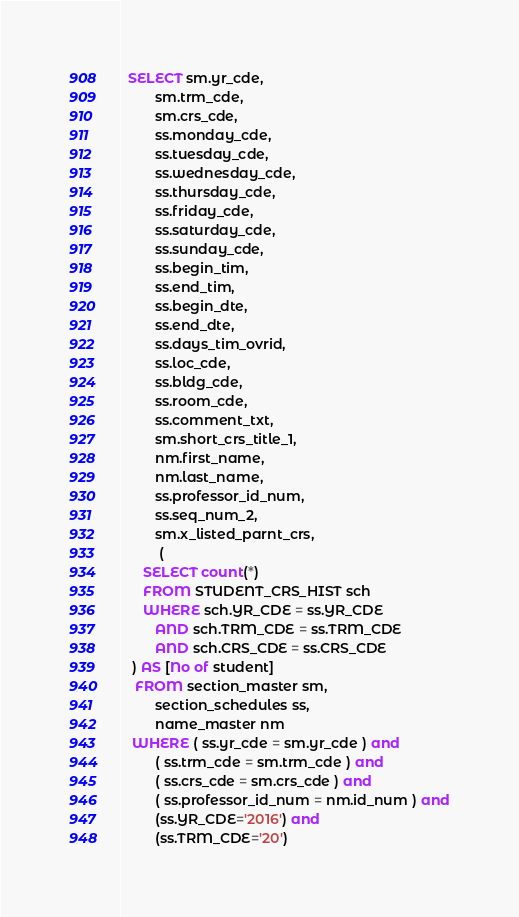Convert code to text. <code><loc_0><loc_0><loc_500><loc_500><_SQL_>  SELECT sm.yr_cde,   
         sm.trm_cde,   
         sm.crs_cde,   
         ss.monday_cde,   
         ss.tuesday_cde,   
         ss.wednesday_cde,   
         ss.thursday_cde,   
         ss.friday_cde,   
         ss.saturday_cde,   
         ss.sunday_cde,   
         ss.begin_tim,   
         ss.end_tim,   
         ss.begin_dte,   
         ss.end_dte,   
         ss.days_tim_ovrid,   
         ss.loc_cde,   
         ss.bldg_cde,   
         ss.room_cde,   
         ss.comment_txt,   
         sm.short_crs_title_1,   
         nm.first_name,   
         nm.last_name,   
         ss.professor_id_num,   
         ss.seq_num_2,   
         sm.x_listed_parnt_crs,
		  (
      SELECT count(*)
      FROM STUDENT_CRS_HIST sch
      WHERE sch.YR_CDE = ss.YR_CDE
         AND sch.TRM_CDE = ss.TRM_CDE
         AND sch.CRS_CDE = ss.CRS_CDE
   ) AS [No of student] 
    FROM section_master sm,   
         section_schedules ss,   
         name_master nm
   WHERE ( ss.yr_cde = sm.yr_cde ) and  
         ( ss.trm_cde = sm.trm_cde ) and  
         ( ss.crs_cde = sm.crs_cde ) and  
         ( ss.professor_id_num = nm.id_num ) and
		 (ss.YR_CDE='2016') and
		 (ss.TRM_CDE='20')  </code> 